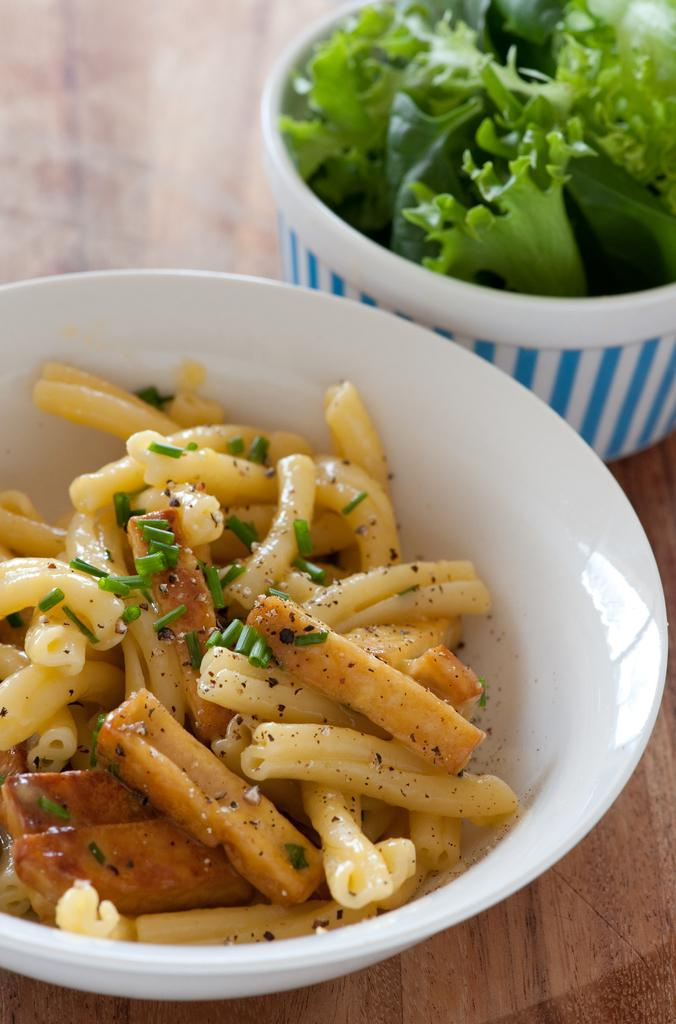What type of containers are visible in the image? There are bowls in the image. What is inside the containers? There are food items in the image. What type of table is present in the image? The wooden table is present in the image. Can you see any sea creatures in the image? There are no sea creatures present in the image. What part of the human body is visible in the image? There are no human body parts visible in the image. 